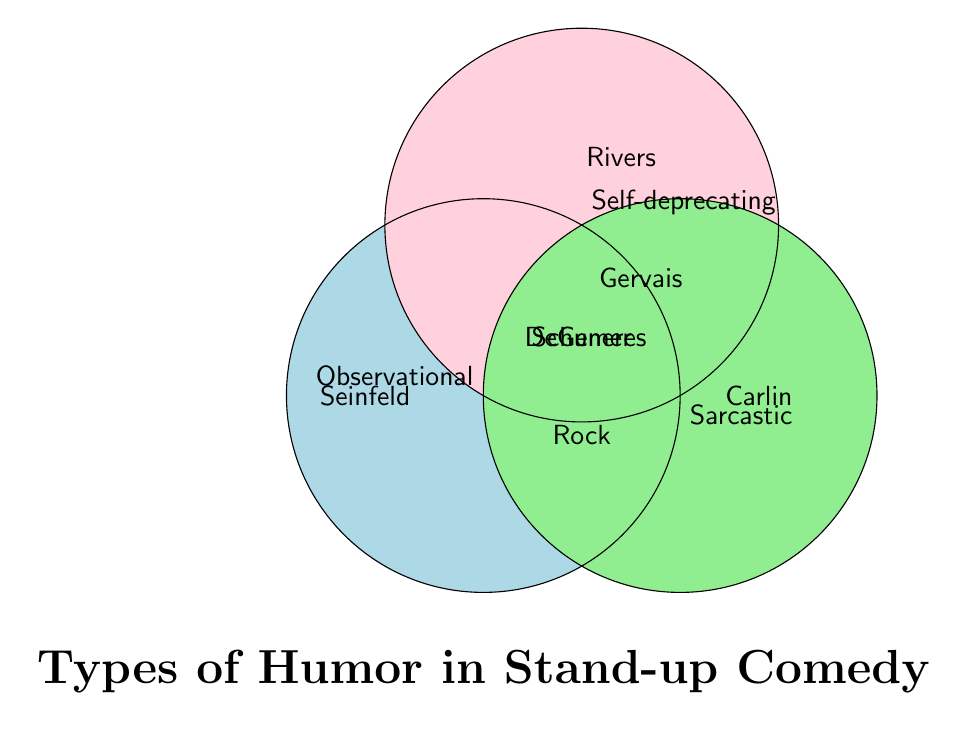Which comedian is associated with Observational humor? Observational humor is denoted by the blue circle. The comedian name within this circle is Seinfeld.
Answer: Seinfeld Which comedian represents all three types of humor? The comedian name in the intersection of all three circles (Observational, Self-deprecating, and Sarcastic) is Schumer.
Answer: Schumer Who is listed under the Self-deprecating humor category? Self-deprecating humor is represented by the pink circle. The comedian names within this circle are Rivers, DeGeneres, Gervais, and Schumer.
Answer: Rivers, DeGeneres, Gervais, Schumer Which comedians have both Observational and Sarcastic humor styles but not Self-deprecating? The intersection of the Observational (blue) and Sarcastic (green) circles that does not overlap with the Self-deprecating (pink) circle has the name Rock.
Answer: Rock Are there any comedians who only use Sarcastic humor without any overlapping humor styles? The only name in the green circle without intersections is Carlin.
Answer: Carlin How many comedians use at least two types of humor? The intersections of the circles represent comedians using multiple humor types. Counting the names: DeGeneres (2), Rock (2), Gervais (2), Schumer (3). In total, there are four names.
Answer: 4 Which comedian would you find in the intersection of Observational and Self-deprecating humor? The intersection of the blue and pink circles contains the name DeGeneres.
Answer: DeGeneres Is there a comedian that appears in both Self-deprecating and Sarcastic but not Observational humor? The intersection of the pink (Self-deprecating) and green (Sarcastic) circles without the blue (Observational) circle contains the name Gervais.
Answer: Gervais 